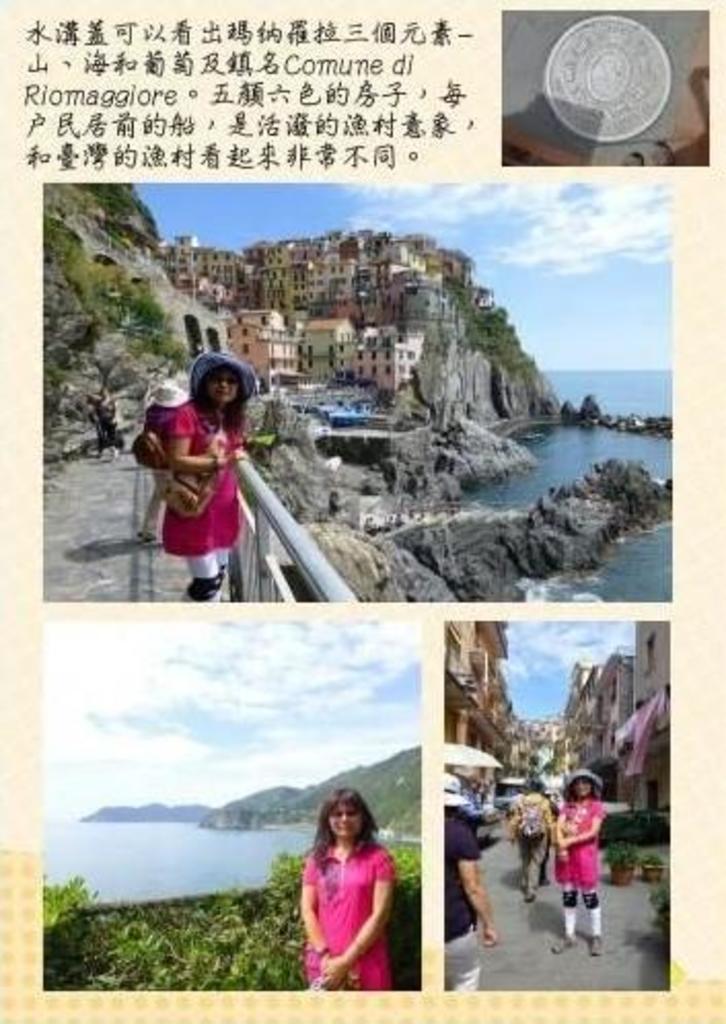Describe this image in one or two sentences. This picture is collage of four different pictures. In the first picture, there is an object. In all the three, there is a woman took the pictures in different places. She is wearing a pink top. In the second picture, there are buildings and hills. In the third picture, there is water and hills. In the fourth picture, there is a street. 